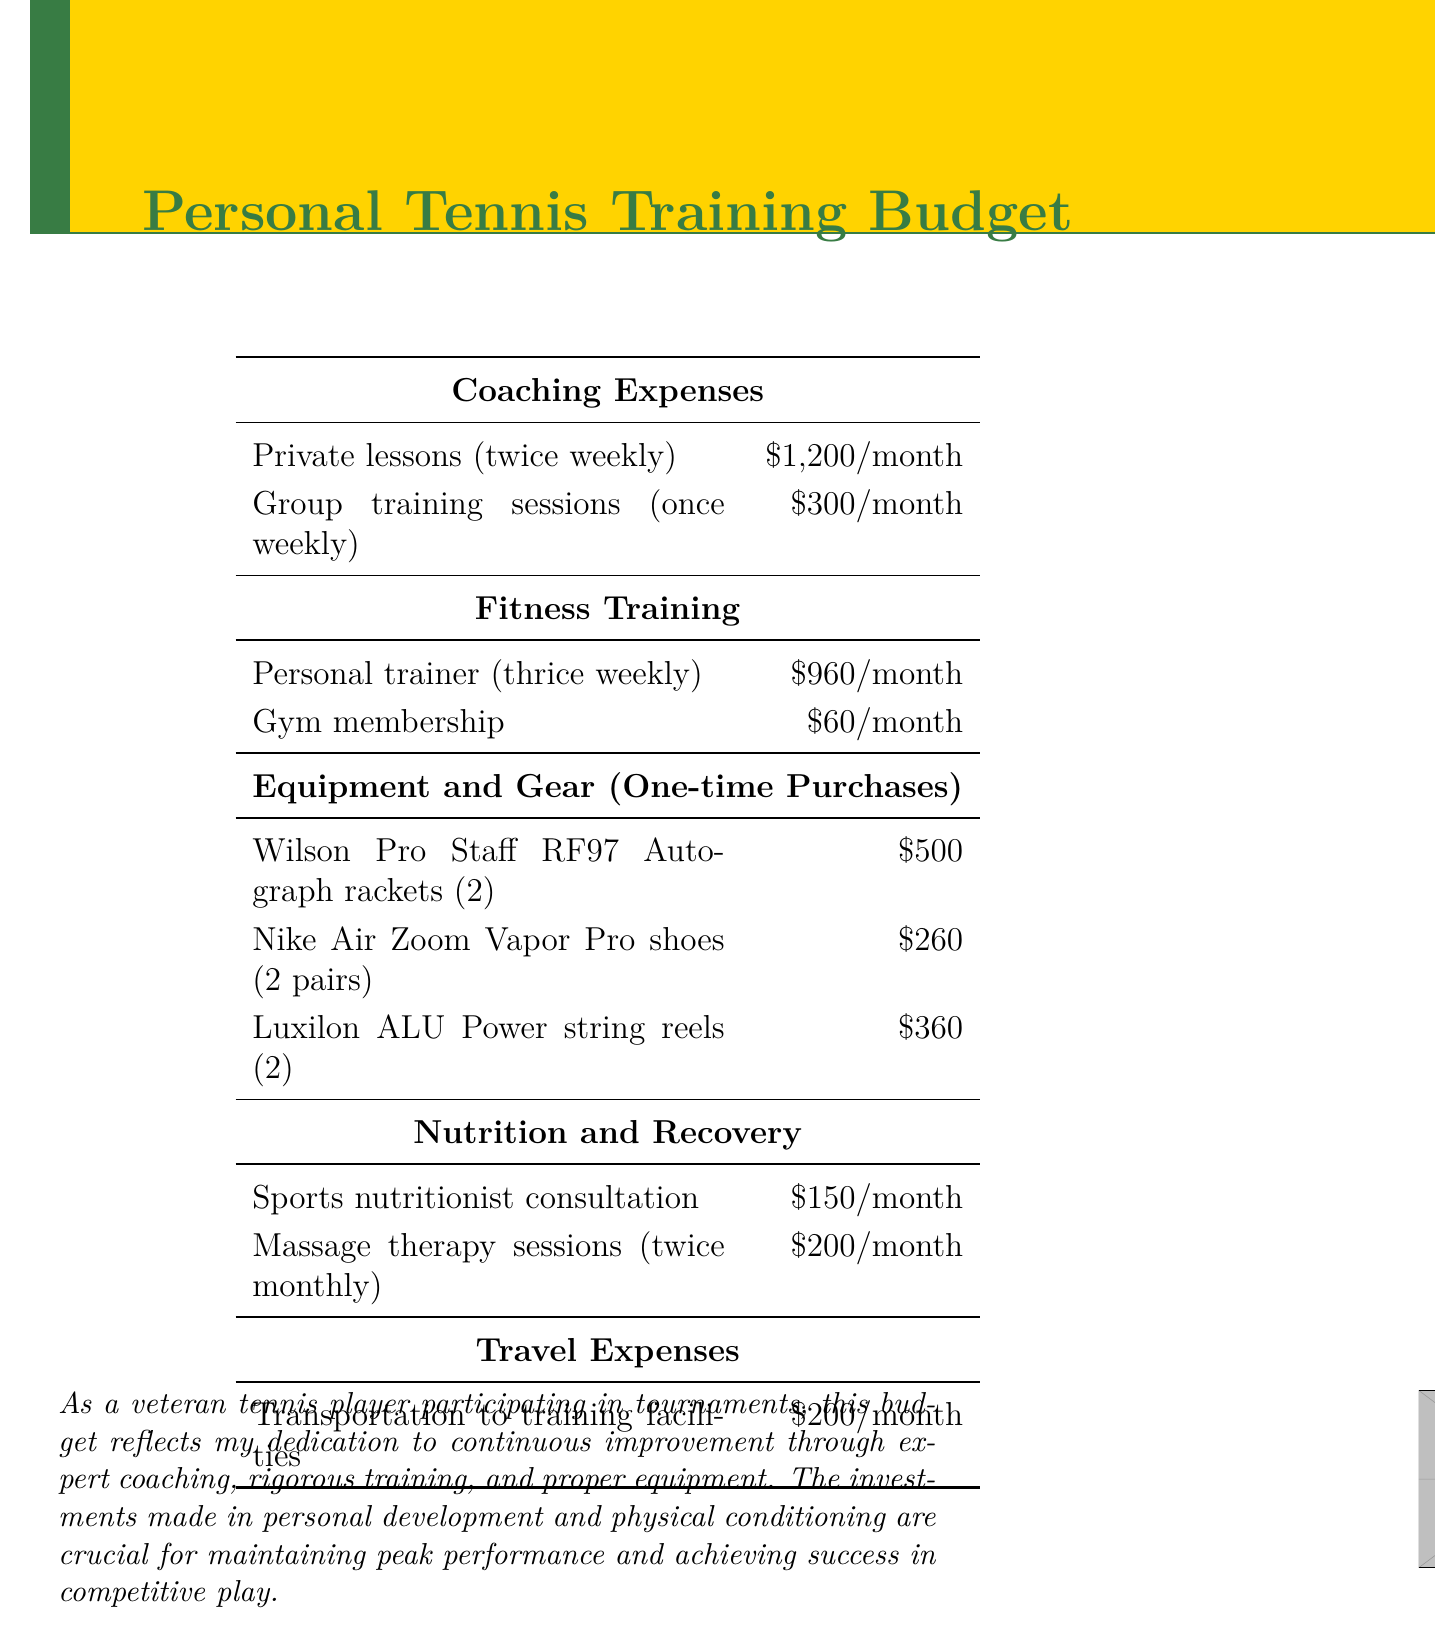what is the monthly cost of private lessons? The document lists the cost of private lessons as $1,200 per month.
Answer: $1,200/month how many times per week is personal training scheduled? The document states that personal training is scheduled three times weekly.
Answer: thrice weekly what is the total cost of the Wilson rackets? The document states the cost of two Wilson Pro Staff RF97 Autograph rackets is $500.
Answer: $500 how much is the gym membership per month? The budget mentions that the gym membership costs $60 per month.
Answer: $60/month what is the total monthly expense for massage therapy sessions? The document indicates that the cost for twice monthly massage therapy sessions is $200.
Answer: $200/month what is the total one-time expense for equipment and gear? The total one-time expenses for equipment and gear can be summed up from the document listed amounts: $500 + $260 + $360 = $1,120.
Answer: $1,120 how often are group training sessions held? The document specifies that group training sessions are held once weekly.
Answer: once weekly what is the monthly transportation cost mentioned? The budget lists transportation to training facilities at a cost of $200 per month.
Answer: $200/month who is responsible for fitness training? The document refers to a personal trainer for fitness training.
Answer: personal trainer 